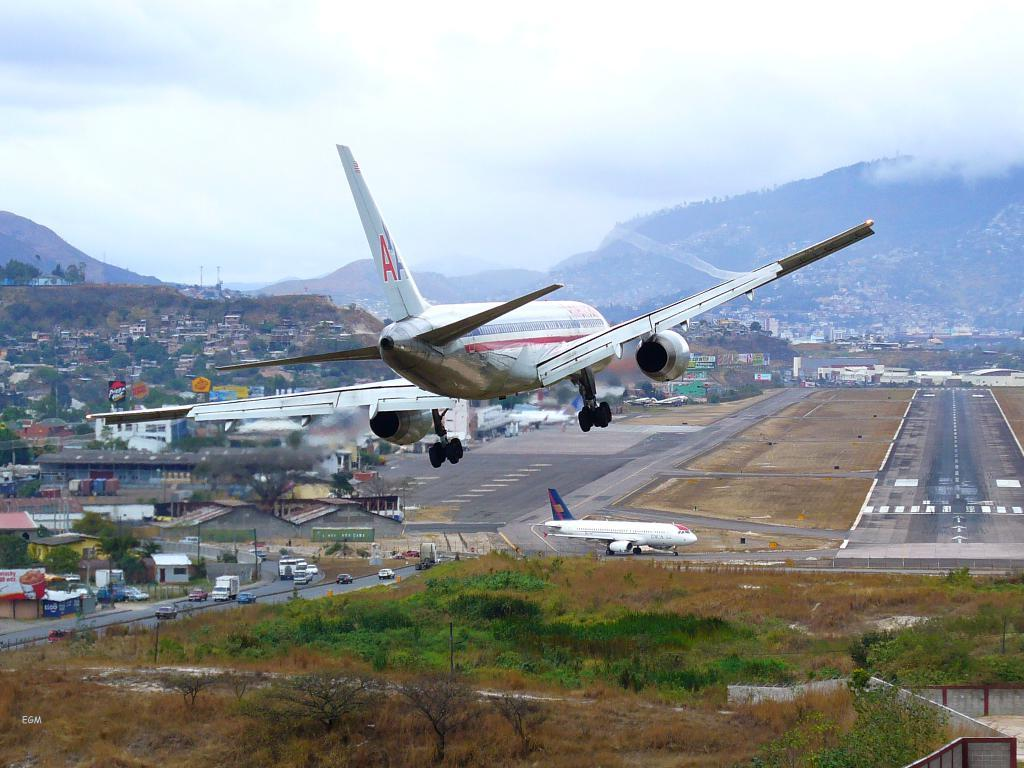What is flying in the air in the image? There is an airplane flying in the air in the image. What structures can be seen in the image? There are buildings in the image. What type of natural elements are present in the image? There are trees and mountains in the image. What type of transportation can be seen on the ground? There are vehicles on the road in the image. What is visible in the background of the image? The sky is visible in the background of the image. What can be observed in the sky? Clouds are present in the sky. How many chairs are placed around the tent in the image? There are no chairs or tents present in the image. What is the value of the quarter on the ground in the image? There is no quarter present in the image. 